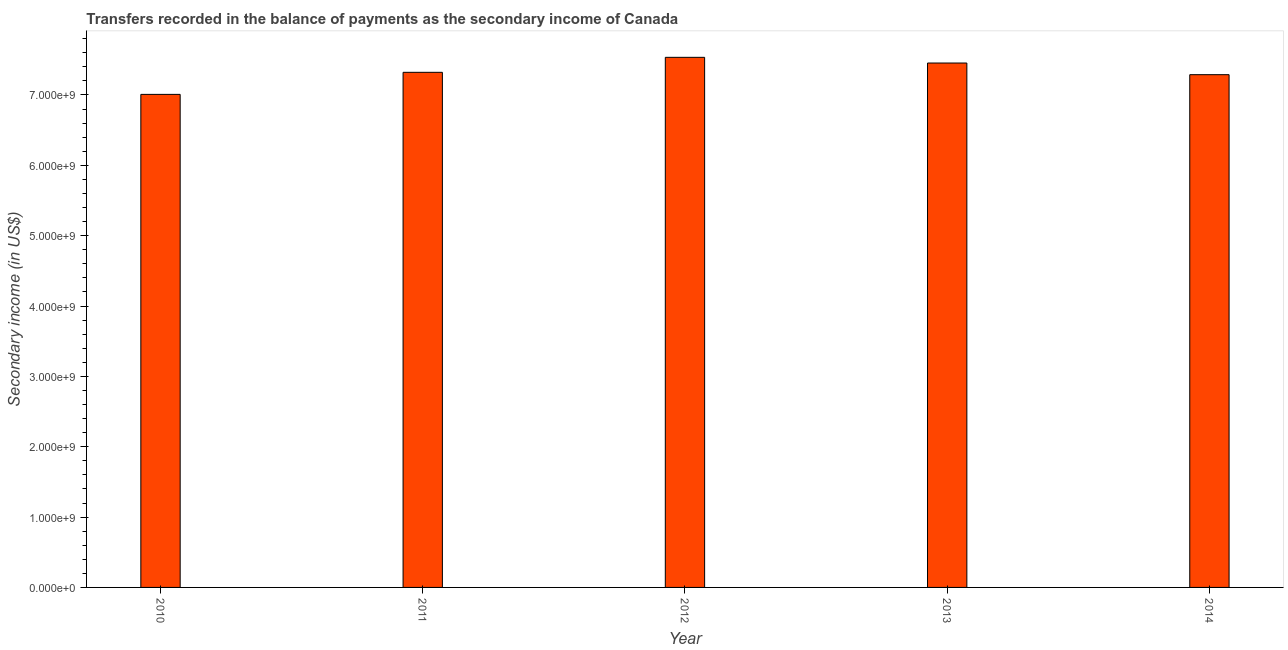Does the graph contain any zero values?
Provide a succinct answer. No. Does the graph contain grids?
Provide a succinct answer. No. What is the title of the graph?
Your answer should be compact. Transfers recorded in the balance of payments as the secondary income of Canada. What is the label or title of the X-axis?
Give a very brief answer. Year. What is the label or title of the Y-axis?
Keep it short and to the point. Secondary income (in US$). What is the amount of secondary income in 2013?
Provide a succinct answer. 7.45e+09. Across all years, what is the maximum amount of secondary income?
Offer a terse response. 7.53e+09. Across all years, what is the minimum amount of secondary income?
Your response must be concise. 7.01e+09. What is the sum of the amount of secondary income?
Offer a very short reply. 3.66e+1. What is the difference between the amount of secondary income in 2011 and 2012?
Ensure brevity in your answer.  -2.13e+08. What is the average amount of secondary income per year?
Give a very brief answer. 7.32e+09. What is the median amount of secondary income?
Provide a short and direct response. 7.32e+09. Do a majority of the years between 2011 and 2013 (inclusive) have amount of secondary income greater than 5000000000 US$?
Offer a terse response. Yes. What is the ratio of the amount of secondary income in 2013 to that in 2014?
Offer a terse response. 1.02. Is the amount of secondary income in 2013 less than that in 2014?
Keep it short and to the point. No. What is the difference between the highest and the second highest amount of secondary income?
Give a very brief answer. 8.09e+07. Is the sum of the amount of secondary income in 2010 and 2012 greater than the maximum amount of secondary income across all years?
Make the answer very short. Yes. What is the difference between the highest and the lowest amount of secondary income?
Your response must be concise. 5.27e+08. In how many years, is the amount of secondary income greater than the average amount of secondary income taken over all years?
Offer a very short reply. 3. Are all the bars in the graph horizontal?
Your response must be concise. No. How many years are there in the graph?
Provide a succinct answer. 5. Are the values on the major ticks of Y-axis written in scientific E-notation?
Keep it short and to the point. Yes. What is the Secondary income (in US$) in 2010?
Your response must be concise. 7.01e+09. What is the Secondary income (in US$) of 2011?
Your response must be concise. 7.32e+09. What is the Secondary income (in US$) of 2012?
Ensure brevity in your answer.  7.53e+09. What is the Secondary income (in US$) of 2013?
Make the answer very short. 7.45e+09. What is the Secondary income (in US$) in 2014?
Your answer should be very brief. 7.29e+09. What is the difference between the Secondary income (in US$) in 2010 and 2011?
Your answer should be very brief. -3.14e+08. What is the difference between the Secondary income (in US$) in 2010 and 2012?
Your answer should be very brief. -5.27e+08. What is the difference between the Secondary income (in US$) in 2010 and 2013?
Ensure brevity in your answer.  -4.46e+08. What is the difference between the Secondary income (in US$) in 2010 and 2014?
Offer a terse response. -2.80e+08. What is the difference between the Secondary income (in US$) in 2011 and 2012?
Offer a terse response. -2.13e+08. What is the difference between the Secondary income (in US$) in 2011 and 2013?
Provide a short and direct response. -1.32e+08. What is the difference between the Secondary income (in US$) in 2011 and 2014?
Give a very brief answer. 3.36e+07. What is the difference between the Secondary income (in US$) in 2012 and 2013?
Provide a short and direct response. 8.09e+07. What is the difference between the Secondary income (in US$) in 2012 and 2014?
Provide a succinct answer. 2.47e+08. What is the difference between the Secondary income (in US$) in 2013 and 2014?
Keep it short and to the point. 1.66e+08. What is the ratio of the Secondary income (in US$) in 2010 to that in 2012?
Offer a very short reply. 0.93. What is the ratio of the Secondary income (in US$) in 2010 to that in 2013?
Your answer should be very brief. 0.94. What is the ratio of the Secondary income (in US$) in 2010 to that in 2014?
Keep it short and to the point. 0.96. What is the ratio of the Secondary income (in US$) in 2011 to that in 2013?
Your answer should be compact. 0.98. What is the ratio of the Secondary income (in US$) in 2012 to that in 2014?
Your response must be concise. 1.03. What is the ratio of the Secondary income (in US$) in 2013 to that in 2014?
Make the answer very short. 1.02. 